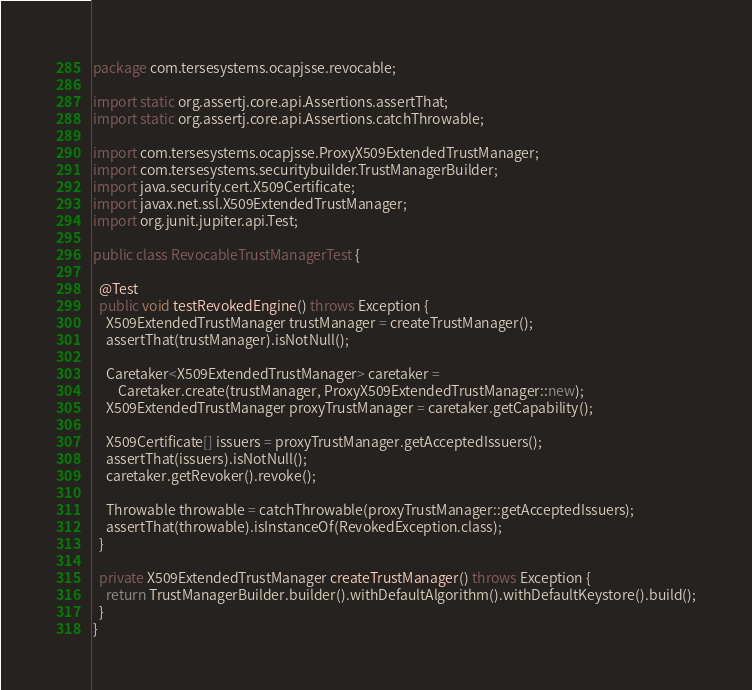Convert code to text. <code><loc_0><loc_0><loc_500><loc_500><_Java_>package com.tersesystems.ocapjsse.revocable;

import static org.assertj.core.api.Assertions.assertThat;
import static org.assertj.core.api.Assertions.catchThrowable;

import com.tersesystems.ocapjsse.ProxyX509ExtendedTrustManager;
import com.tersesystems.securitybuilder.TrustManagerBuilder;
import java.security.cert.X509Certificate;
import javax.net.ssl.X509ExtendedTrustManager;
import org.junit.jupiter.api.Test;

public class RevocableTrustManagerTest {

  @Test
  public void testRevokedEngine() throws Exception {
    X509ExtendedTrustManager trustManager = createTrustManager();
    assertThat(trustManager).isNotNull();

    Caretaker<X509ExtendedTrustManager> caretaker =
        Caretaker.create(trustManager, ProxyX509ExtendedTrustManager::new);
    X509ExtendedTrustManager proxyTrustManager = caretaker.getCapability();

    X509Certificate[] issuers = proxyTrustManager.getAcceptedIssuers();
    assertThat(issuers).isNotNull();
    caretaker.getRevoker().revoke();

    Throwable throwable = catchThrowable(proxyTrustManager::getAcceptedIssuers);
    assertThat(throwable).isInstanceOf(RevokedException.class);
  }

  private X509ExtendedTrustManager createTrustManager() throws Exception {
    return TrustManagerBuilder.builder().withDefaultAlgorithm().withDefaultKeystore().build();
  }
}
</code> 